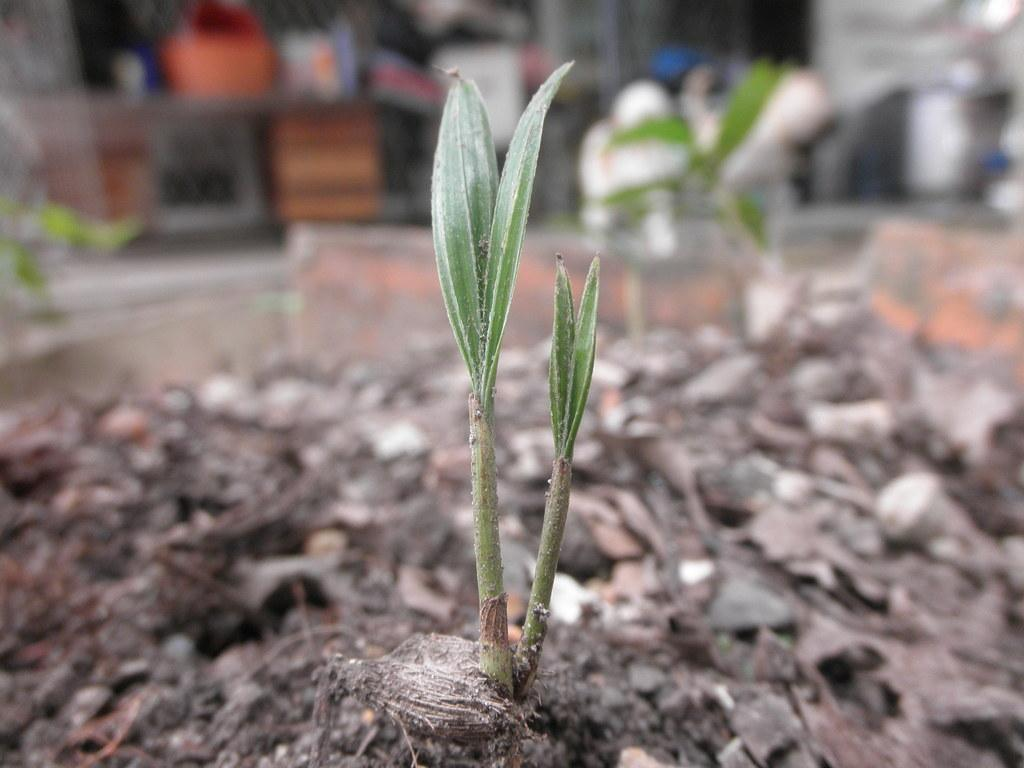What is present in the image? There is a plant in the image. Can you describe the background of the image? There are blurred objects behind the plant in the image. What is the reason for the rainstorm in the image? There is no rainstorm present in the image; it only features a plant and blurred objects in the background. 